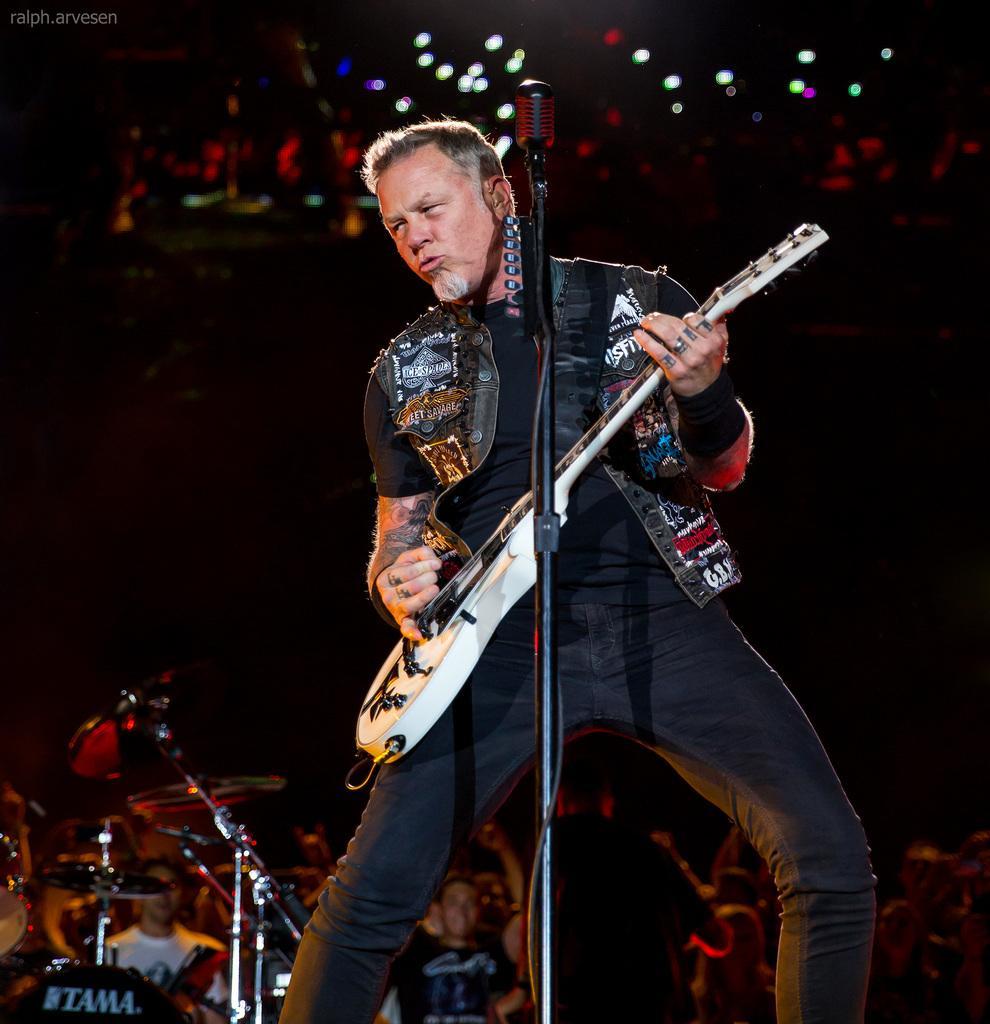In one or two sentences, can you explain what this image depicts? In this picture we can see man standing holding guitar in his hand and playing it and singing on mic and in background we can see a group of people standing and we can see drums, light and it is dark. 